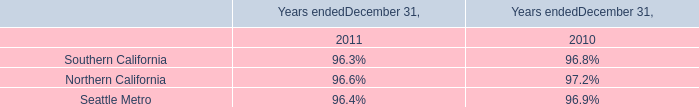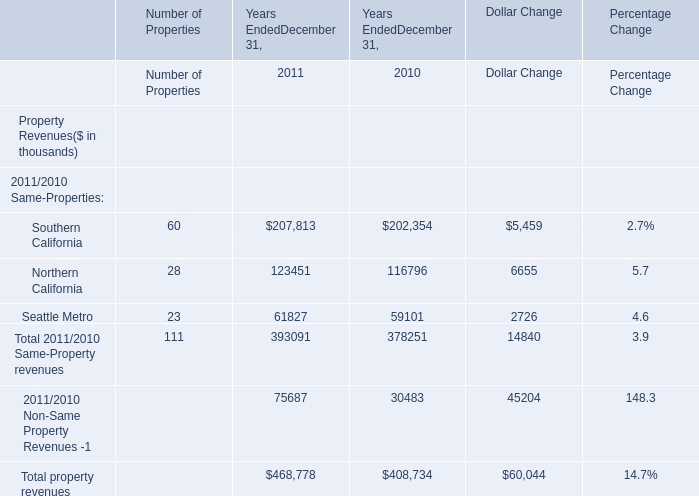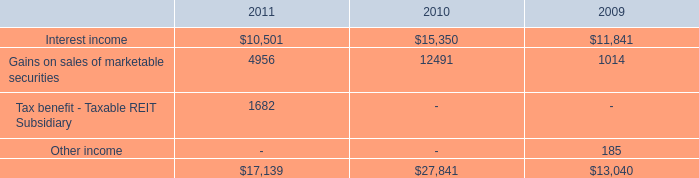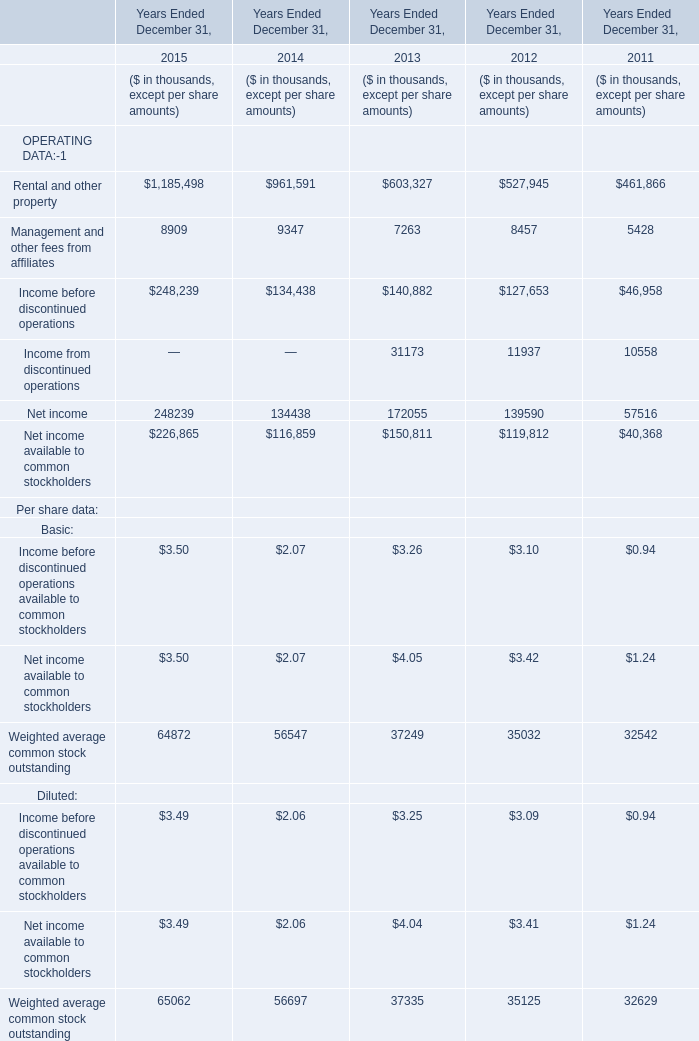What will Rental and other property be like in 2016 if it develops with the same increasing rate as current? (in thousands) 
Computations: ((1 + ((1185498 - 961591) / 961591)) * 1185498)
Answer: 1461541.86968. 